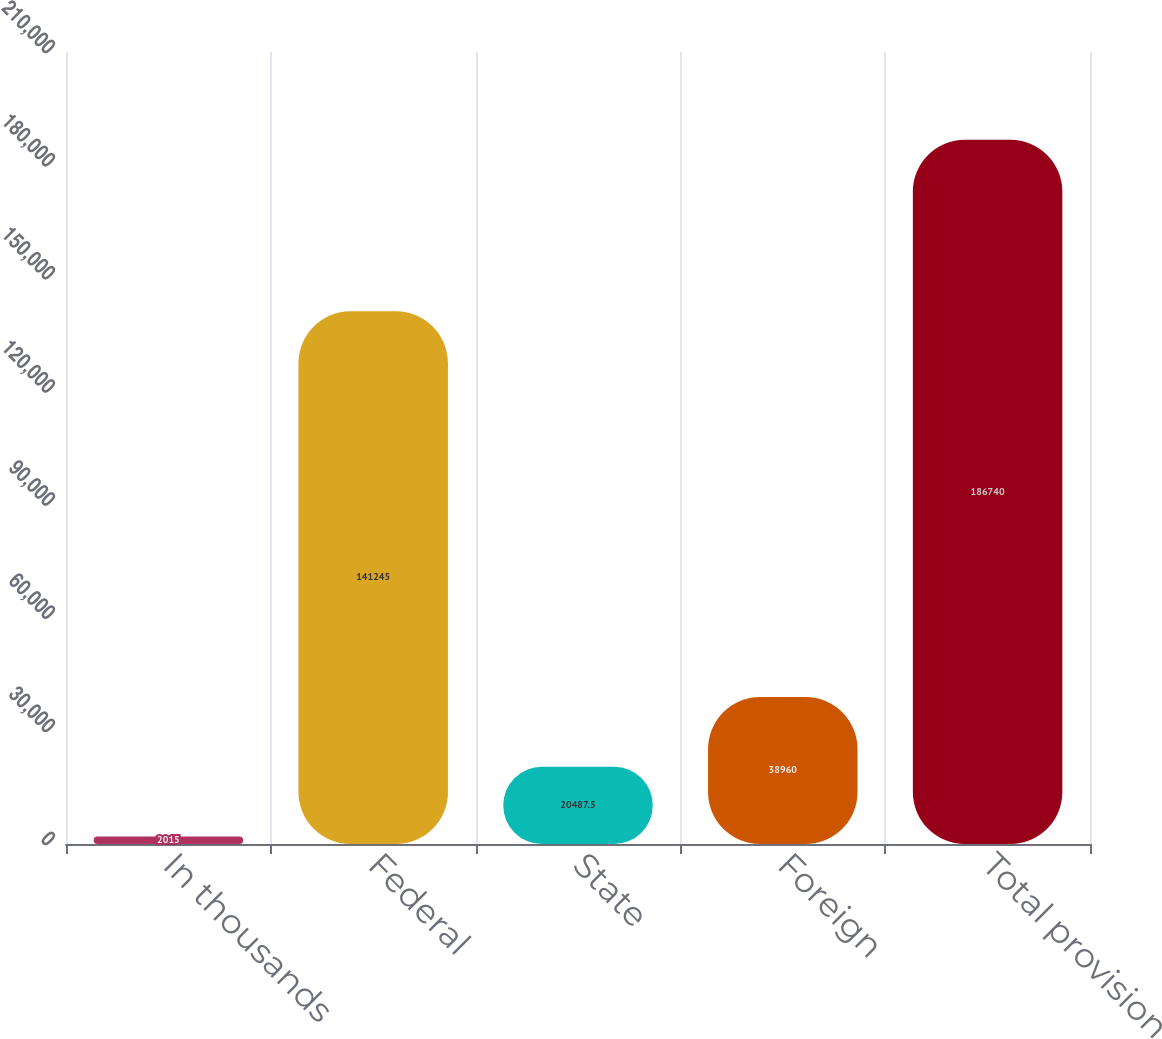Convert chart. <chart><loc_0><loc_0><loc_500><loc_500><bar_chart><fcel>In thousands<fcel>Federal<fcel>State<fcel>Foreign<fcel>Total provision<nl><fcel>2015<fcel>141245<fcel>20487.5<fcel>38960<fcel>186740<nl></chart> 